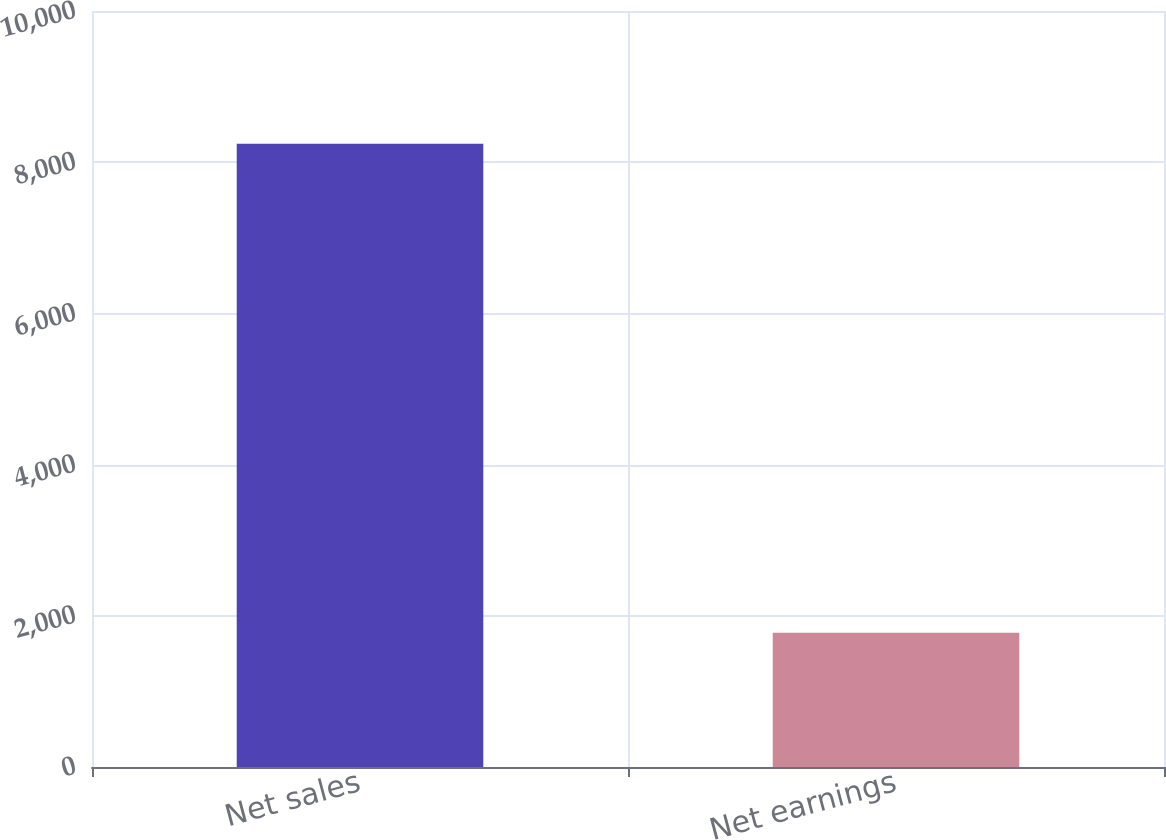Convert chart to OTSL. <chart><loc_0><loc_0><loc_500><loc_500><bar_chart><fcel>Net sales<fcel>Net earnings<nl><fcel>8245<fcel>1775<nl></chart> 